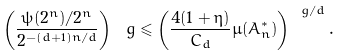<formula> <loc_0><loc_0><loc_500><loc_500>\left ( \frac { \psi ( 2 ^ { n } ) / 2 ^ { n } } { 2 ^ { - ( d + 1 ) n / d } } \right ) ^ { \ } g \leqslant \left ( \frac { 4 ( 1 + \eta ) } { C _ { d } } \mu ( A _ { n } ^ { \ast } ) \right ) ^ { \ g / d } .</formula> 